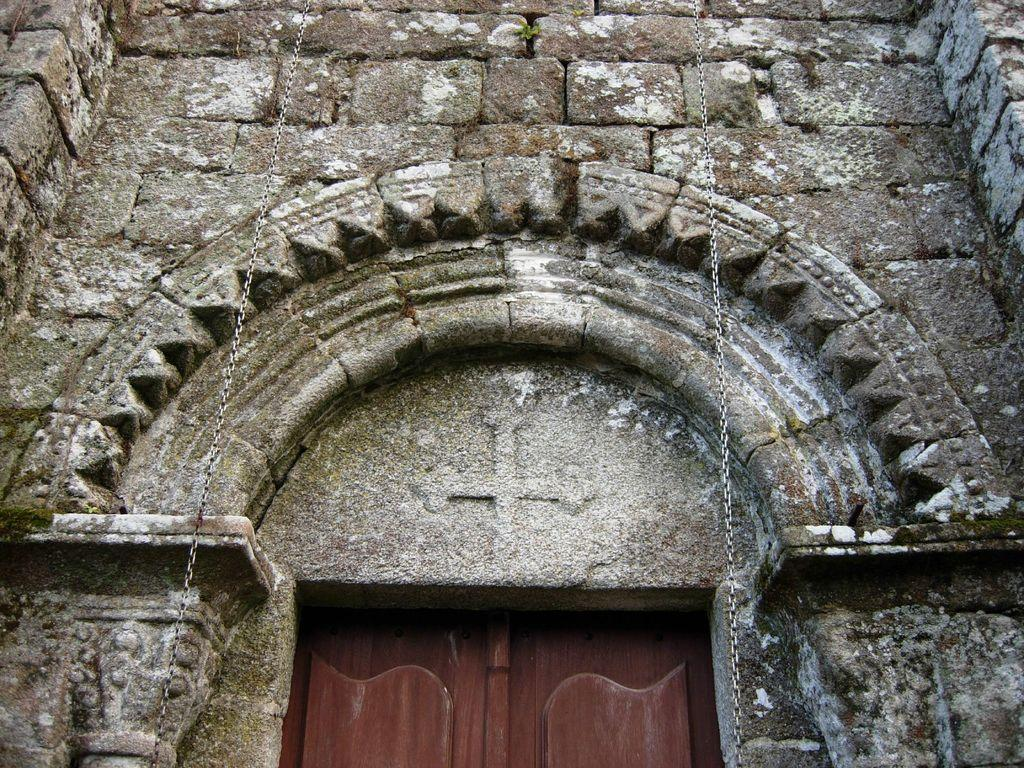What type of structure is present in the image? There is a wall in the image. Can you describe the appearance of an object in the image? There is a brown color thing in the image. How many chains can be seen in the image? There are two silver color chains in the image. How does the carpenter use the cheese to tie a knot in the image? There is no carpenter, cheese, or knot present in the image. 